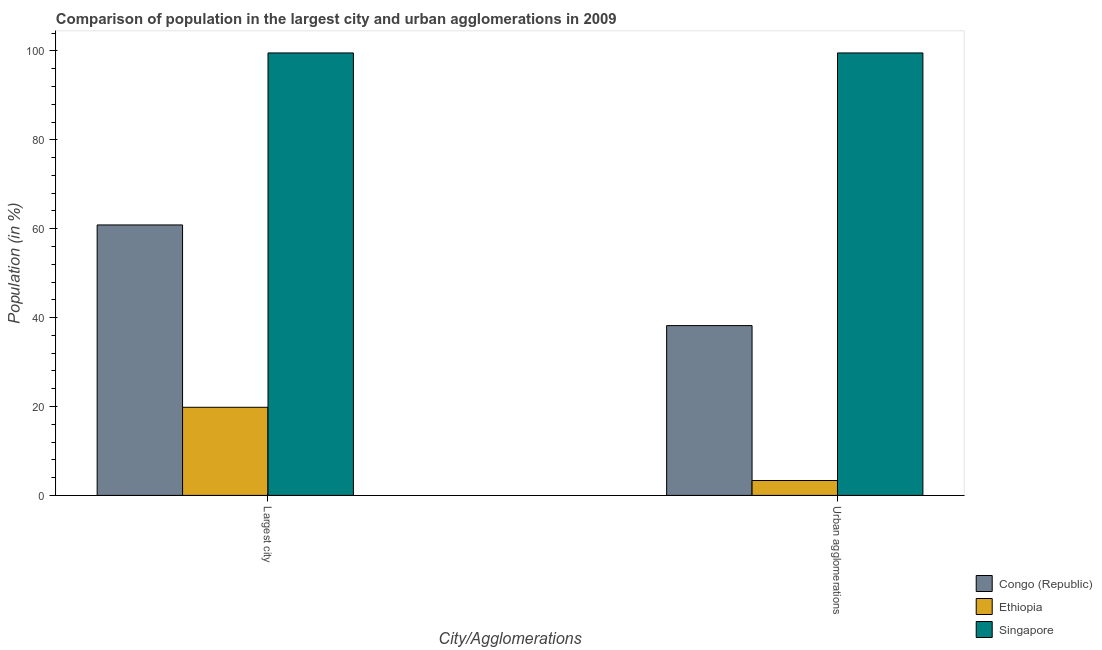How many different coloured bars are there?
Provide a succinct answer. 3. How many groups of bars are there?
Keep it short and to the point. 2. How many bars are there on the 1st tick from the left?
Make the answer very short. 3. What is the label of the 1st group of bars from the left?
Provide a short and direct response. Largest city. What is the population in urban agglomerations in Ethiopia?
Provide a succinct answer. 3.35. Across all countries, what is the maximum population in urban agglomerations?
Make the answer very short. 99.53. Across all countries, what is the minimum population in the largest city?
Offer a very short reply. 19.82. In which country was the population in the largest city maximum?
Your answer should be very brief. Singapore. In which country was the population in urban agglomerations minimum?
Give a very brief answer. Ethiopia. What is the total population in urban agglomerations in the graph?
Provide a succinct answer. 141.09. What is the difference between the population in urban agglomerations in Ethiopia and that in Congo (Republic)?
Keep it short and to the point. -34.85. What is the difference between the population in the largest city in Ethiopia and the population in urban agglomerations in Singapore?
Provide a short and direct response. -79.71. What is the average population in the largest city per country?
Provide a short and direct response. 60.07. What is the difference between the population in the largest city and population in urban agglomerations in Ethiopia?
Ensure brevity in your answer.  16.47. In how many countries, is the population in urban agglomerations greater than 4 %?
Offer a terse response. 2. What is the ratio of the population in the largest city in Congo (Republic) to that in Singapore?
Keep it short and to the point. 0.61. Is the population in urban agglomerations in Congo (Republic) less than that in Ethiopia?
Ensure brevity in your answer.  No. What does the 2nd bar from the left in Urban agglomerations represents?
Offer a terse response. Ethiopia. What does the 1st bar from the right in Urban agglomerations represents?
Your response must be concise. Singapore. How many bars are there?
Your answer should be very brief. 6. Are all the bars in the graph horizontal?
Offer a very short reply. No. How many legend labels are there?
Offer a very short reply. 3. What is the title of the graph?
Make the answer very short. Comparison of population in the largest city and urban agglomerations in 2009. What is the label or title of the X-axis?
Offer a very short reply. City/Agglomerations. What is the label or title of the Y-axis?
Offer a very short reply. Population (in %). What is the Population (in %) of Congo (Republic) in Largest city?
Ensure brevity in your answer.  60.84. What is the Population (in %) in Ethiopia in Largest city?
Give a very brief answer. 19.82. What is the Population (in %) in Singapore in Largest city?
Your response must be concise. 99.53. What is the Population (in %) in Congo (Republic) in Urban agglomerations?
Your answer should be very brief. 38.2. What is the Population (in %) in Ethiopia in Urban agglomerations?
Give a very brief answer. 3.35. What is the Population (in %) of Singapore in Urban agglomerations?
Give a very brief answer. 99.53. Across all City/Agglomerations, what is the maximum Population (in %) of Congo (Republic)?
Your answer should be compact. 60.84. Across all City/Agglomerations, what is the maximum Population (in %) in Ethiopia?
Provide a short and direct response. 19.82. Across all City/Agglomerations, what is the maximum Population (in %) in Singapore?
Provide a succinct answer. 99.53. Across all City/Agglomerations, what is the minimum Population (in %) of Congo (Republic)?
Offer a terse response. 38.2. Across all City/Agglomerations, what is the minimum Population (in %) of Ethiopia?
Make the answer very short. 3.35. Across all City/Agglomerations, what is the minimum Population (in %) in Singapore?
Offer a very short reply. 99.53. What is the total Population (in %) of Congo (Republic) in the graph?
Your answer should be very brief. 99.04. What is the total Population (in %) of Ethiopia in the graph?
Offer a very short reply. 23.18. What is the total Population (in %) in Singapore in the graph?
Give a very brief answer. 199.07. What is the difference between the Population (in %) in Congo (Republic) in Largest city and that in Urban agglomerations?
Ensure brevity in your answer.  22.64. What is the difference between the Population (in %) in Ethiopia in Largest city and that in Urban agglomerations?
Your answer should be compact. 16.47. What is the difference between the Population (in %) in Singapore in Largest city and that in Urban agglomerations?
Provide a succinct answer. 0. What is the difference between the Population (in %) of Congo (Republic) in Largest city and the Population (in %) of Ethiopia in Urban agglomerations?
Keep it short and to the point. 57.49. What is the difference between the Population (in %) in Congo (Republic) in Largest city and the Population (in %) in Singapore in Urban agglomerations?
Make the answer very short. -38.69. What is the difference between the Population (in %) of Ethiopia in Largest city and the Population (in %) of Singapore in Urban agglomerations?
Make the answer very short. -79.71. What is the average Population (in %) of Congo (Republic) per City/Agglomerations?
Provide a short and direct response. 49.52. What is the average Population (in %) in Ethiopia per City/Agglomerations?
Your answer should be very brief. 11.59. What is the average Population (in %) in Singapore per City/Agglomerations?
Ensure brevity in your answer.  99.53. What is the difference between the Population (in %) in Congo (Republic) and Population (in %) in Ethiopia in Largest city?
Keep it short and to the point. 41.02. What is the difference between the Population (in %) of Congo (Republic) and Population (in %) of Singapore in Largest city?
Your answer should be very brief. -38.69. What is the difference between the Population (in %) in Ethiopia and Population (in %) in Singapore in Largest city?
Offer a terse response. -79.71. What is the difference between the Population (in %) in Congo (Republic) and Population (in %) in Ethiopia in Urban agglomerations?
Your answer should be very brief. 34.85. What is the difference between the Population (in %) in Congo (Republic) and Population (in %) in Singapore in Urban agglomerations?
Your answer should be compact. -61.33. What is the difference between the Population (in %) of Ethiopia and Population (in %) of Singapore in Urban agglomerations?
Give a very brief answer. -96.18. What is the ratio of the Population (in %) in Congo (Republic) in Largest city to that in Urban agglomerations?
Provide a succinct answer. 1.59. What is the ratio of the Population (in %) of Ethiopia in Largest city to that in Urban agglomerations?
Your answer should be compact. 5.91. What is the ratio of the Population (in %) in Singapore in Largest city to that in Urban agglomerations?
Your answer should be very brief. 1. What is the difference between the highest and the second highest Population (in %) of Congo (Republic)?
Offer a terse response. 22.64. What is the difference between the highest and the second highest Population (in %) in Ethiopia?
Offer a very short reply. 16.47. What is the difference between the highest and the lowest Population (in %) of Congo (Republic)?
Make the answer very short. 22.64. What is the difference between the highest and the lowest Population (in %) of Ethiopia?
Keep it short and to the point. 16.47. What is the difference between the highest and the lowest Population (in %) in Singapore?
Offer a terse response. 0. 